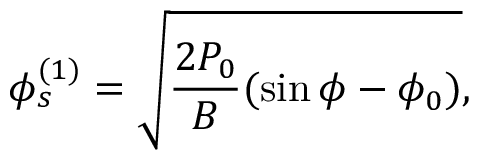<formula> <loc_0><loc_0><loc_500><loc_500>\phi _ { s } ^ { ( 1 ) } = \sqrt { \frac { 2 P _ { 0 } } { B } ( \sin \phi - \phi _ { 0 } ) } ,</formula> 